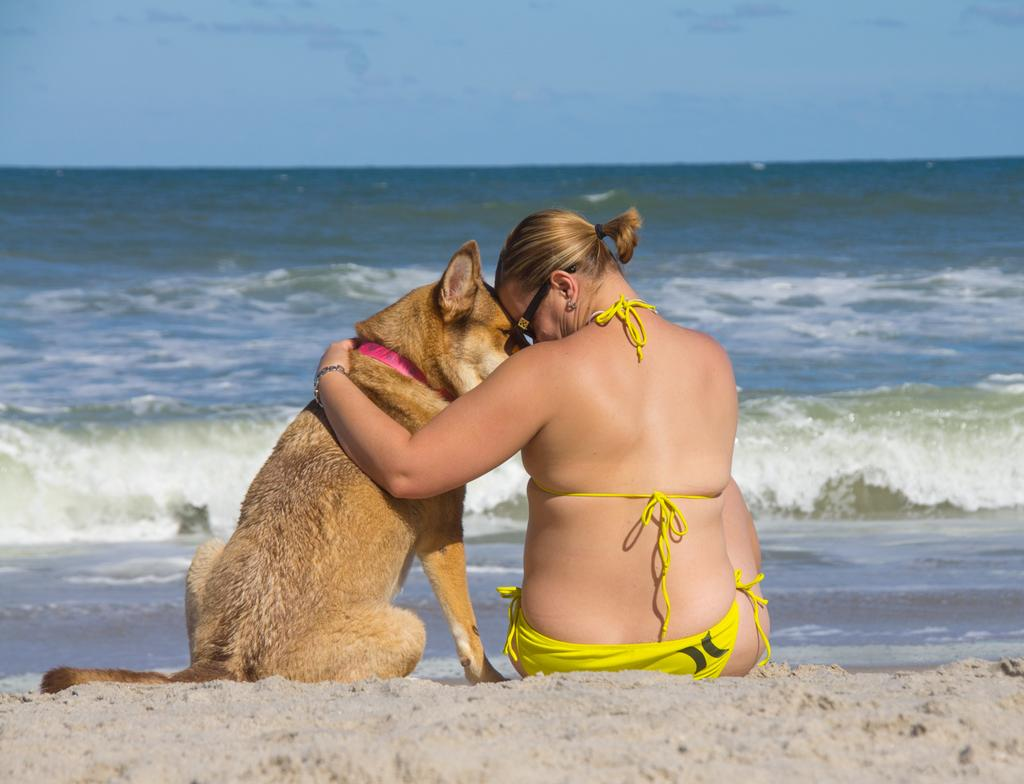Who or what can be seen in the image besides the sand? There is a person and a dog in the image. What are the person and the dog doing in the image? Both the person and the dog are sitting on the sand. What else is visible in the image besides the sand and the subjects? There is water and the sky visible in the image. What type of advertisement can be seen on the person's mask in the image? There is no mask present in the image, and therefore no advertisement can be seen on it. 